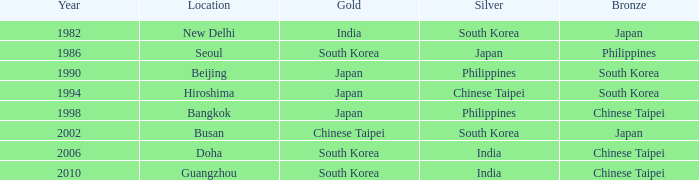Help me parse the entirety of this table. {'header': ['Year', 'Location', 'Gold', 'Silver', 'Bronze'], 'rows': [['1982', 'New Delhi', 'India', 'South Korea', 'Japan'], ['1986', 'Seoul', 'South Korea', 'Japan', 'Philippines'], ['1990', 'Beijing', 'Japan', 'Philippines', 'South Korea'], ['1994', 'Hiroshima', 'Japan', 'Chinese Taipei', 'South Korea'], ['1998', 'Bangkok', 'Japan', 'Philippines', 'Chinese Taipei'], ['2002', 'Busan', 'Chinese Taipei', 'South Korea', 'Japan'], ['2006', 'Doha', 'South Korea', 'India', 'Chinese Taipei'], ['2010', 'Guangzhou', 'South Korea', 'India', 'Chinese Taipei']]} Where is a japanese silver located? Seoul. 